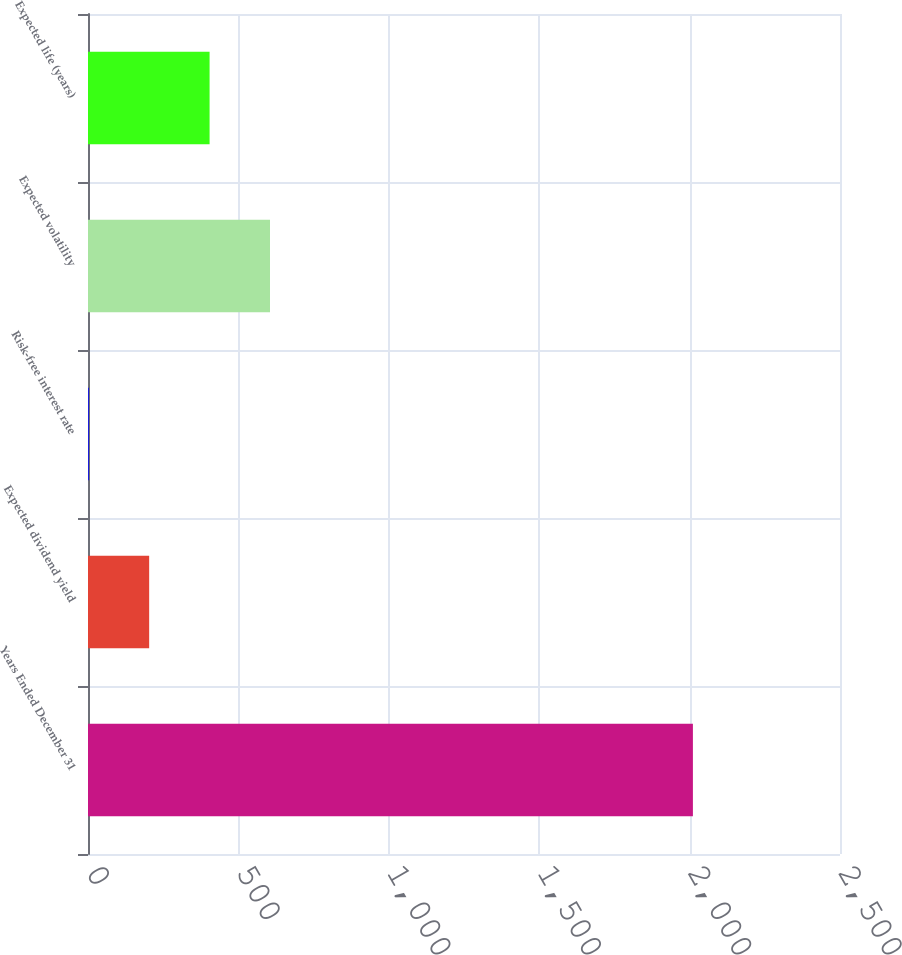Convert chart. <chart><loc_0><loc_0><loc_500><loc_500><bar_chart><fcel>Years Ended December 31<fcel>Expected dividend yield<fcel>Risk-free interest rate<fcel>Expected volatility<fcel>Expected life (years)<nl><fcel>2011<fcel>203.35<fcel>2.5<fcel>605.05<fcel>404.2<nl></chart> 